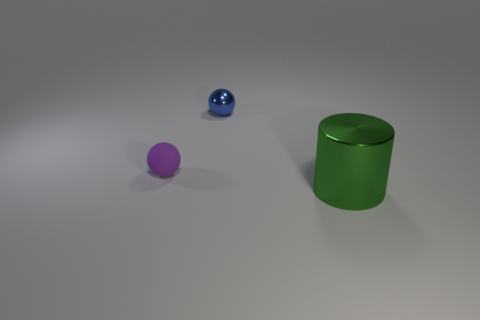How does the lighting in the image affect the appearance of the objects? The lighting creates subtle shadows and highlights, giving the objects a three-dimensional look. It appears to be coming from the upper left, casting shadows to the right and slightly downwards, emphasizing the texture and color of the objects. 